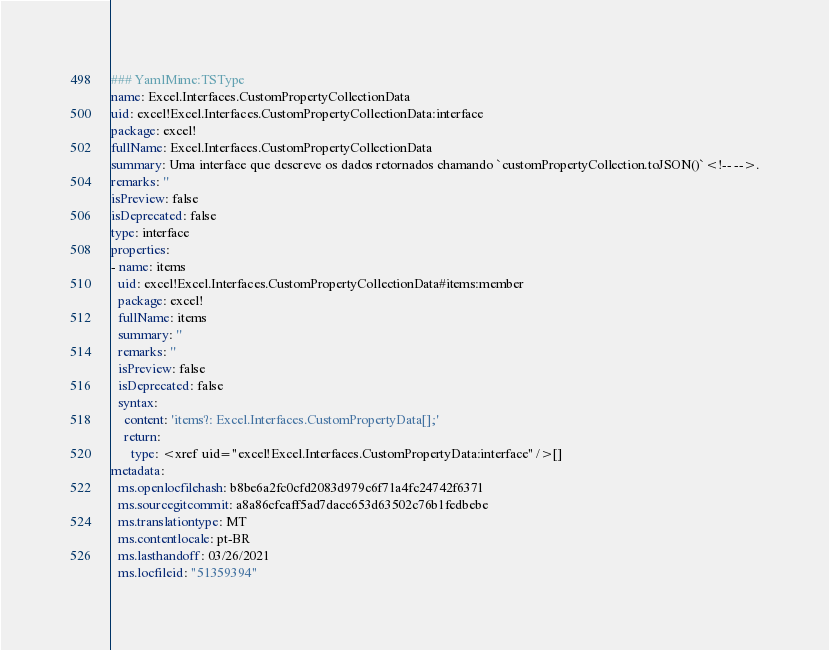<code> <loc_0><loc_0><loc_500><loc_500><_YAML_>### YamlMime:TSType
name: Excel.Interfaces.CustomPropertyCollectionData
uid: excel!Excel.Interfaces.CustomPropertyCollectionData:interface
package: excel!
fullName: Excel.Interfaces.CustomPropertyCollectionData
summary: Uma interface que descreve os dados retornados chamando `customPropertyCollection.toJSON()`<!-- -->.
remarks: ''
isPreview: false
isDeprecated: false
type: interface
properties:
- name: items
  uid: excel!Excel.Interfaces.CustomPropertyCollectionData#items:member
  package: excel!
  fullName: items
  summary: ''
  remarks: ''
  isPreview: false
  isDeprecated: false
  syntax:
    content: 'items?: Excel.Interfaces.CustomPropertyData[];'
    return:
      type: <xref uid="excel!Excel.Interfaces.CustomPropertyData:interface" />[]
metadata:
  ms.openlocfilehash: b8be6a2fc0cfd2083d979c6f71a4fc24742f6371
  ms.sourcegitcommit: a8a86cfcaff5ad7dacc653d63502c76b1fedbebe
  ms.translationtype: MT
  ms.contentlocale: pt-BR
  ms.lasthandoff: 03/26/2021
  ms.locfileid: "51359394"
</code> 